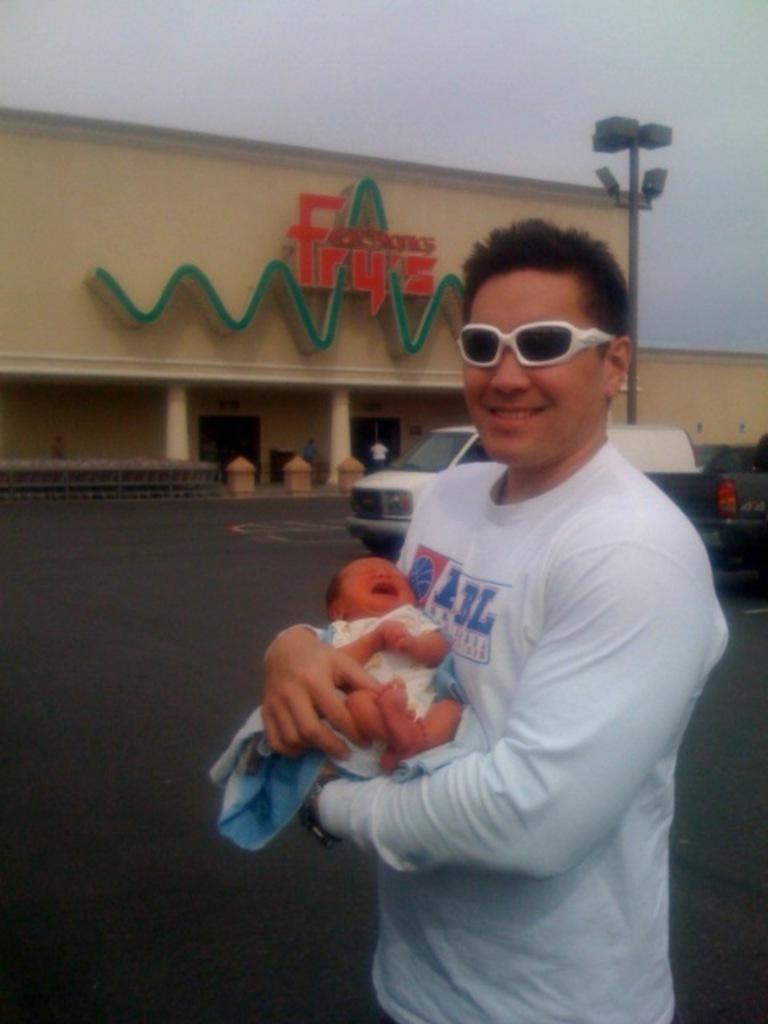Can you describe this image briefly? In this image we can see a man carrying a baby. Behind the man we can see vehicles, building, person and a pole with lights. On the building we can see the design and text. At the top we can see the sky. 